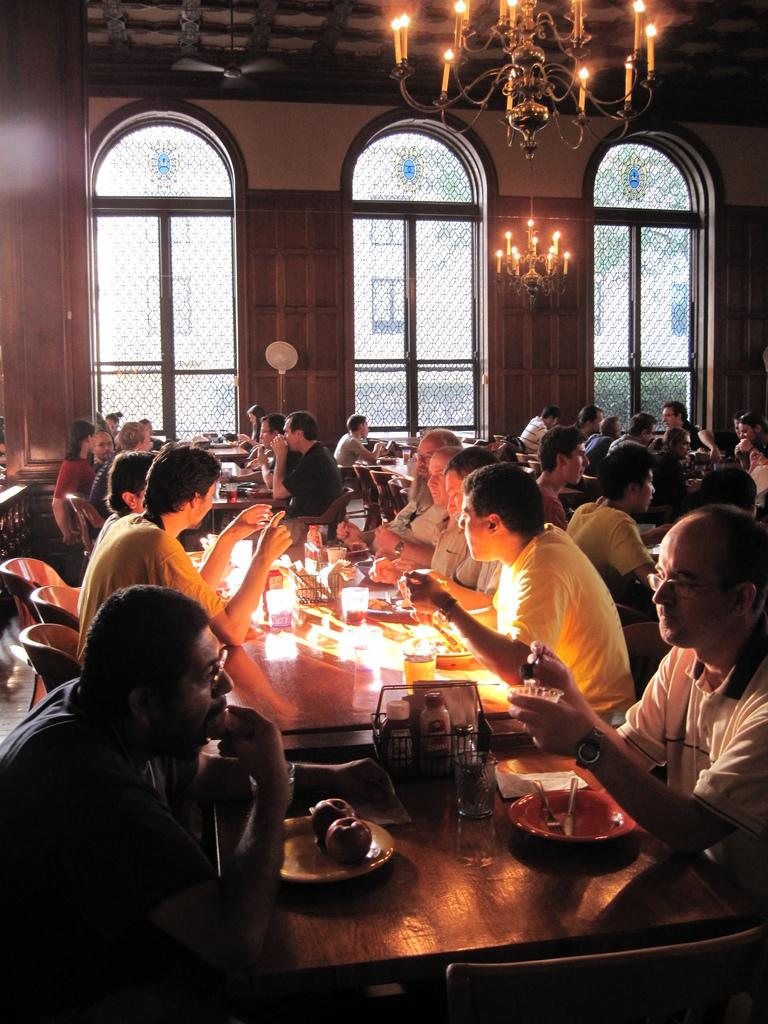What is happening in the image involving the group of people? The people in the image are sitting on chairs and having food. What can be seen in the background of the image? There is a glass window and a roof with a lightning arrangement in the image. What type of list can be seen on the table in the image? There is no list present on the table in the image. What is the clam used for in the image? There is no clam present in the image. 